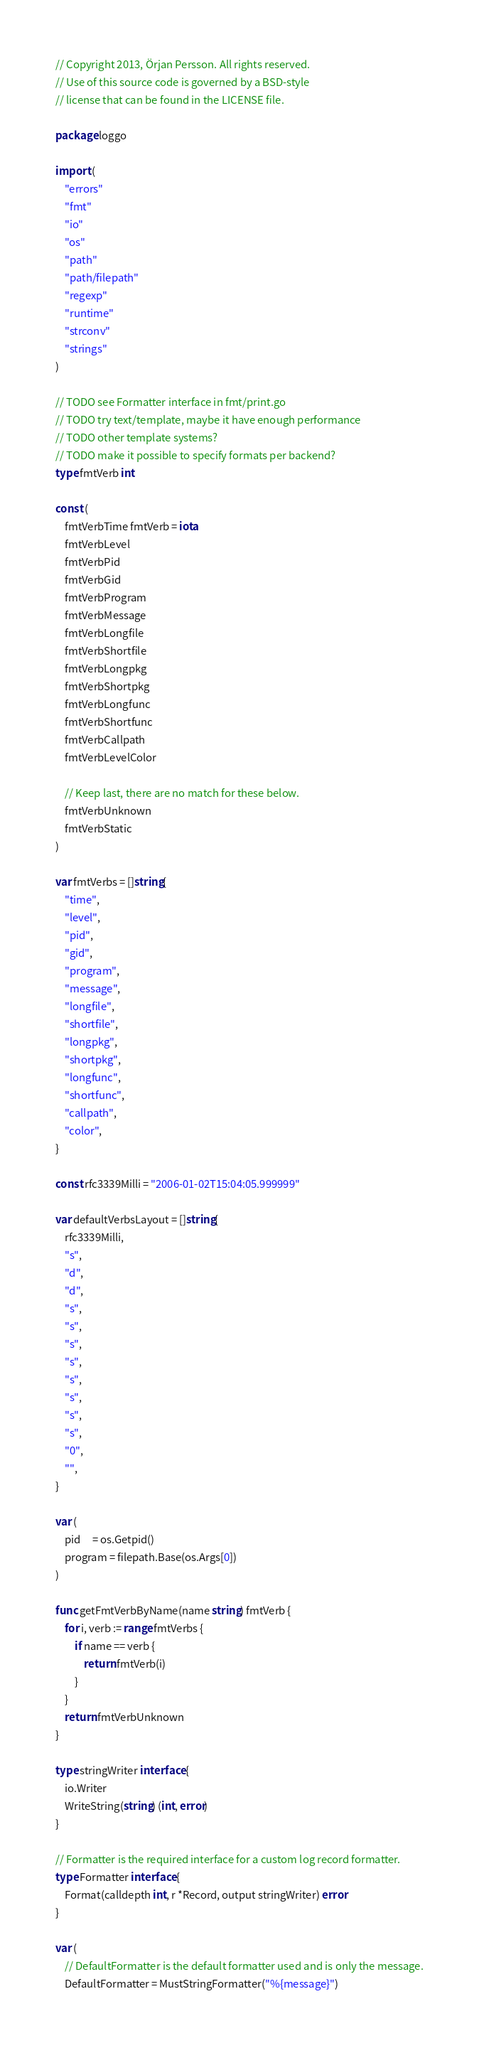<code> <loc_0><loc_0><loc_500><loc_500><_Go_>// Copyright 2013, Örjan Persson. All rights reserved.
// Use of this source code is governed by a BSD-style
// license that can be found in the LICENSE file.

package loggo

import (
	"errors"
	"fmt"
	"io"
	"os"
	"path"
	"path/filepath"
	"regexp"
	"runtime"
	"strconv"
	"strings"
)

// TODO see Formatter interface in fmt/print.go
// TODO try text/template, maybe it have enough performance
// TODO other template systems?
// TODO make it possible to specify formats per backend?
type fmtVerb int

const (
	fmtVerbTime fmtVerb = iota
	fmtVerbLevel
	fmtVerbPid
	fmtVerbGid
	fmtVerbProgram
	fmtVerbMessage
	fmtVerbLongfile
	fmtVerbShortfile
	fmtVerbLongpkg
	fmtVerbShortpkg
	fmtVerbLongfunc
	fmtVerbShortfunc
	fmtVerbCallpath
	fmtVerbLevelColor

	// Keep last, there are no match for these below.
	fmtVerbUnknown
	fmtVerbStatic
)

var fmtVerbs = []string{
	"time",
	"level",
	"pid",
	"gid",
	"program",
	"message",
	"longfile",
	"shortfile",
	"longpkg",
	"shortpkg",
	"longfunc",
	"shortfunc",
	"callpath",
	"color",
}

const rfc3339Milli = "2006-01-02T15:04:05.999999"

var defaultVerbsLayout = []string{
	rfc3339Milli,
	"s",
	"d",
	"d",
	"s",
	"s",
	"s",
	"s",
	"s",
	"s",
	"s",
	"s",
	"0",
	"",
}

var (
	pid     = os.Getpid()
	program = filepath.Base(os.Args[0])
)

func getFmtVerbByName(name string) fmtVerb {
	for i, verb := range fmtVerbs {
		if name == verb {
			return fmtVerb(i)
		}
	}
	return fmtVerbUnknown
}

type stringWriter interface {
	io.Writer
	WriteString(string) (int, error)
}

// Formatter is the required interface for a custom log record formatter.
type Formatter interface {
	Format(calldepth int, r *Record, output stringWriter) error
}

var (
	// DefaultFormatter is the default formatter used and is only the message.
	DefaultFormatter = MustStringFormatter("%{message}")
</code> 